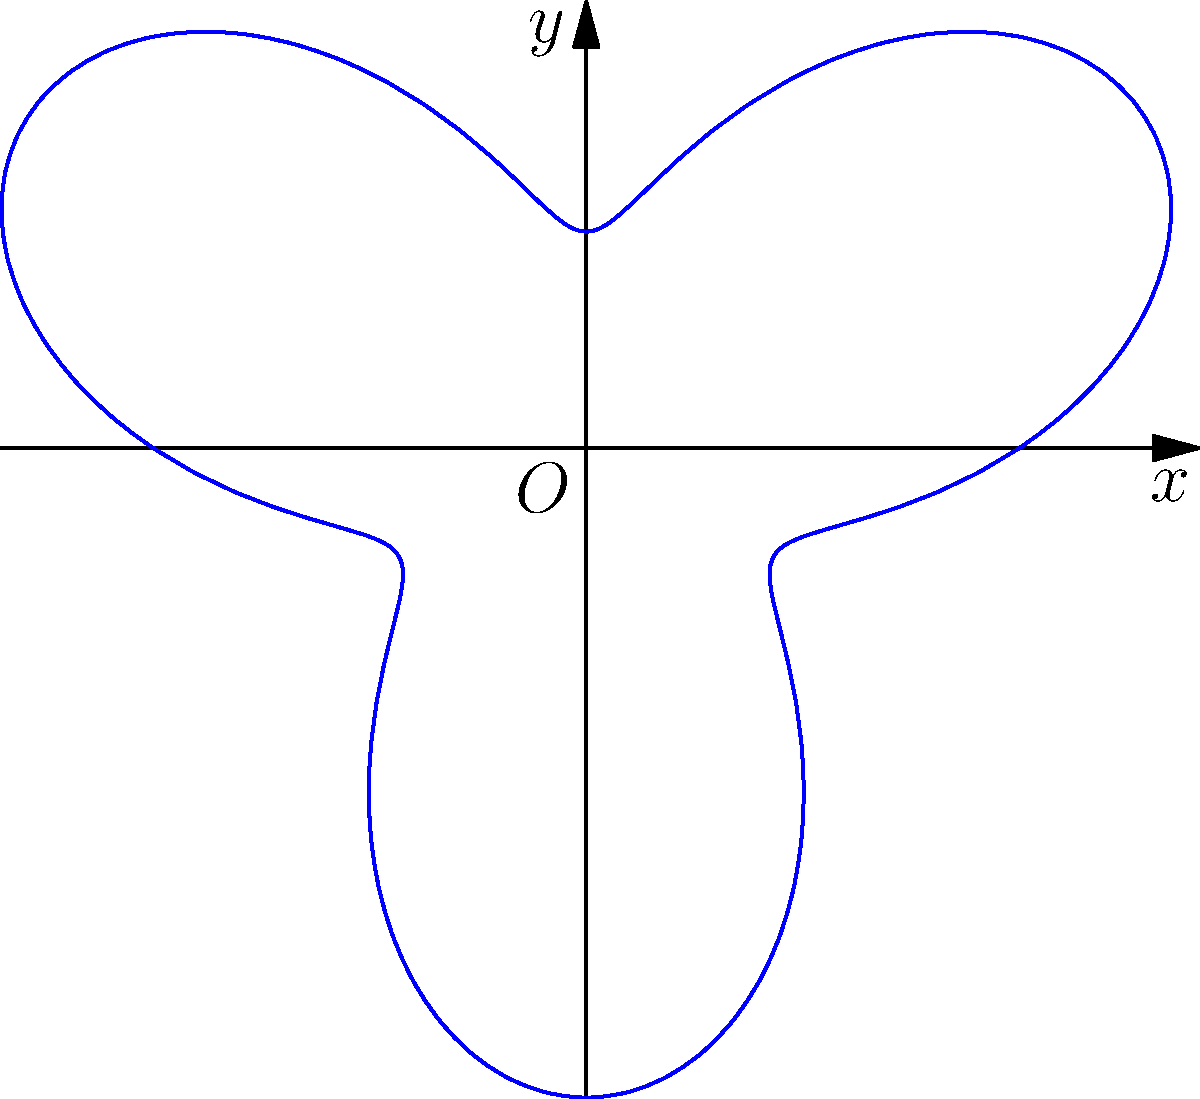In a 360-degree animated scene, the camera's motion path is represented by the polar equation $r = 2 + \sin(3\theta)$. What is the maximum distance the camera reaches from the origin, and how many times does it reach this distance in one complete revolution? To solve this problem, we need to follow these steps:

1. Identify the general form of the polar equation:
   $r = 2 + \sin(3\theta)$

2. Find the maximum value of $r$:
   - The maximum occurs when $\sin(3\theta)$ reaches its maximum value of 1.
   - Therefore, $r_{max} = 2 + 1 = 3$

3. Determine how many times this maximum is reached in one revolution:
   - One complete revolution corresponds to $\theta$ going from 0 to $2\pi$.
   - $\sin(3\theta)$ completes 3 full cycles in this range.
   - Each cycle has two points where $\sin(3\theta) = 1$ (its maximum value).

4. Calculate the total number of times the maximum is reached:
   - Number of times = 3 cycles × 2 maxima per cycle = 6

Therefore, the camera reaches a maximum distance of 3 units from the origin, and it does so 6 times in one complete revolution.
Answer: 3 units; 6 times 